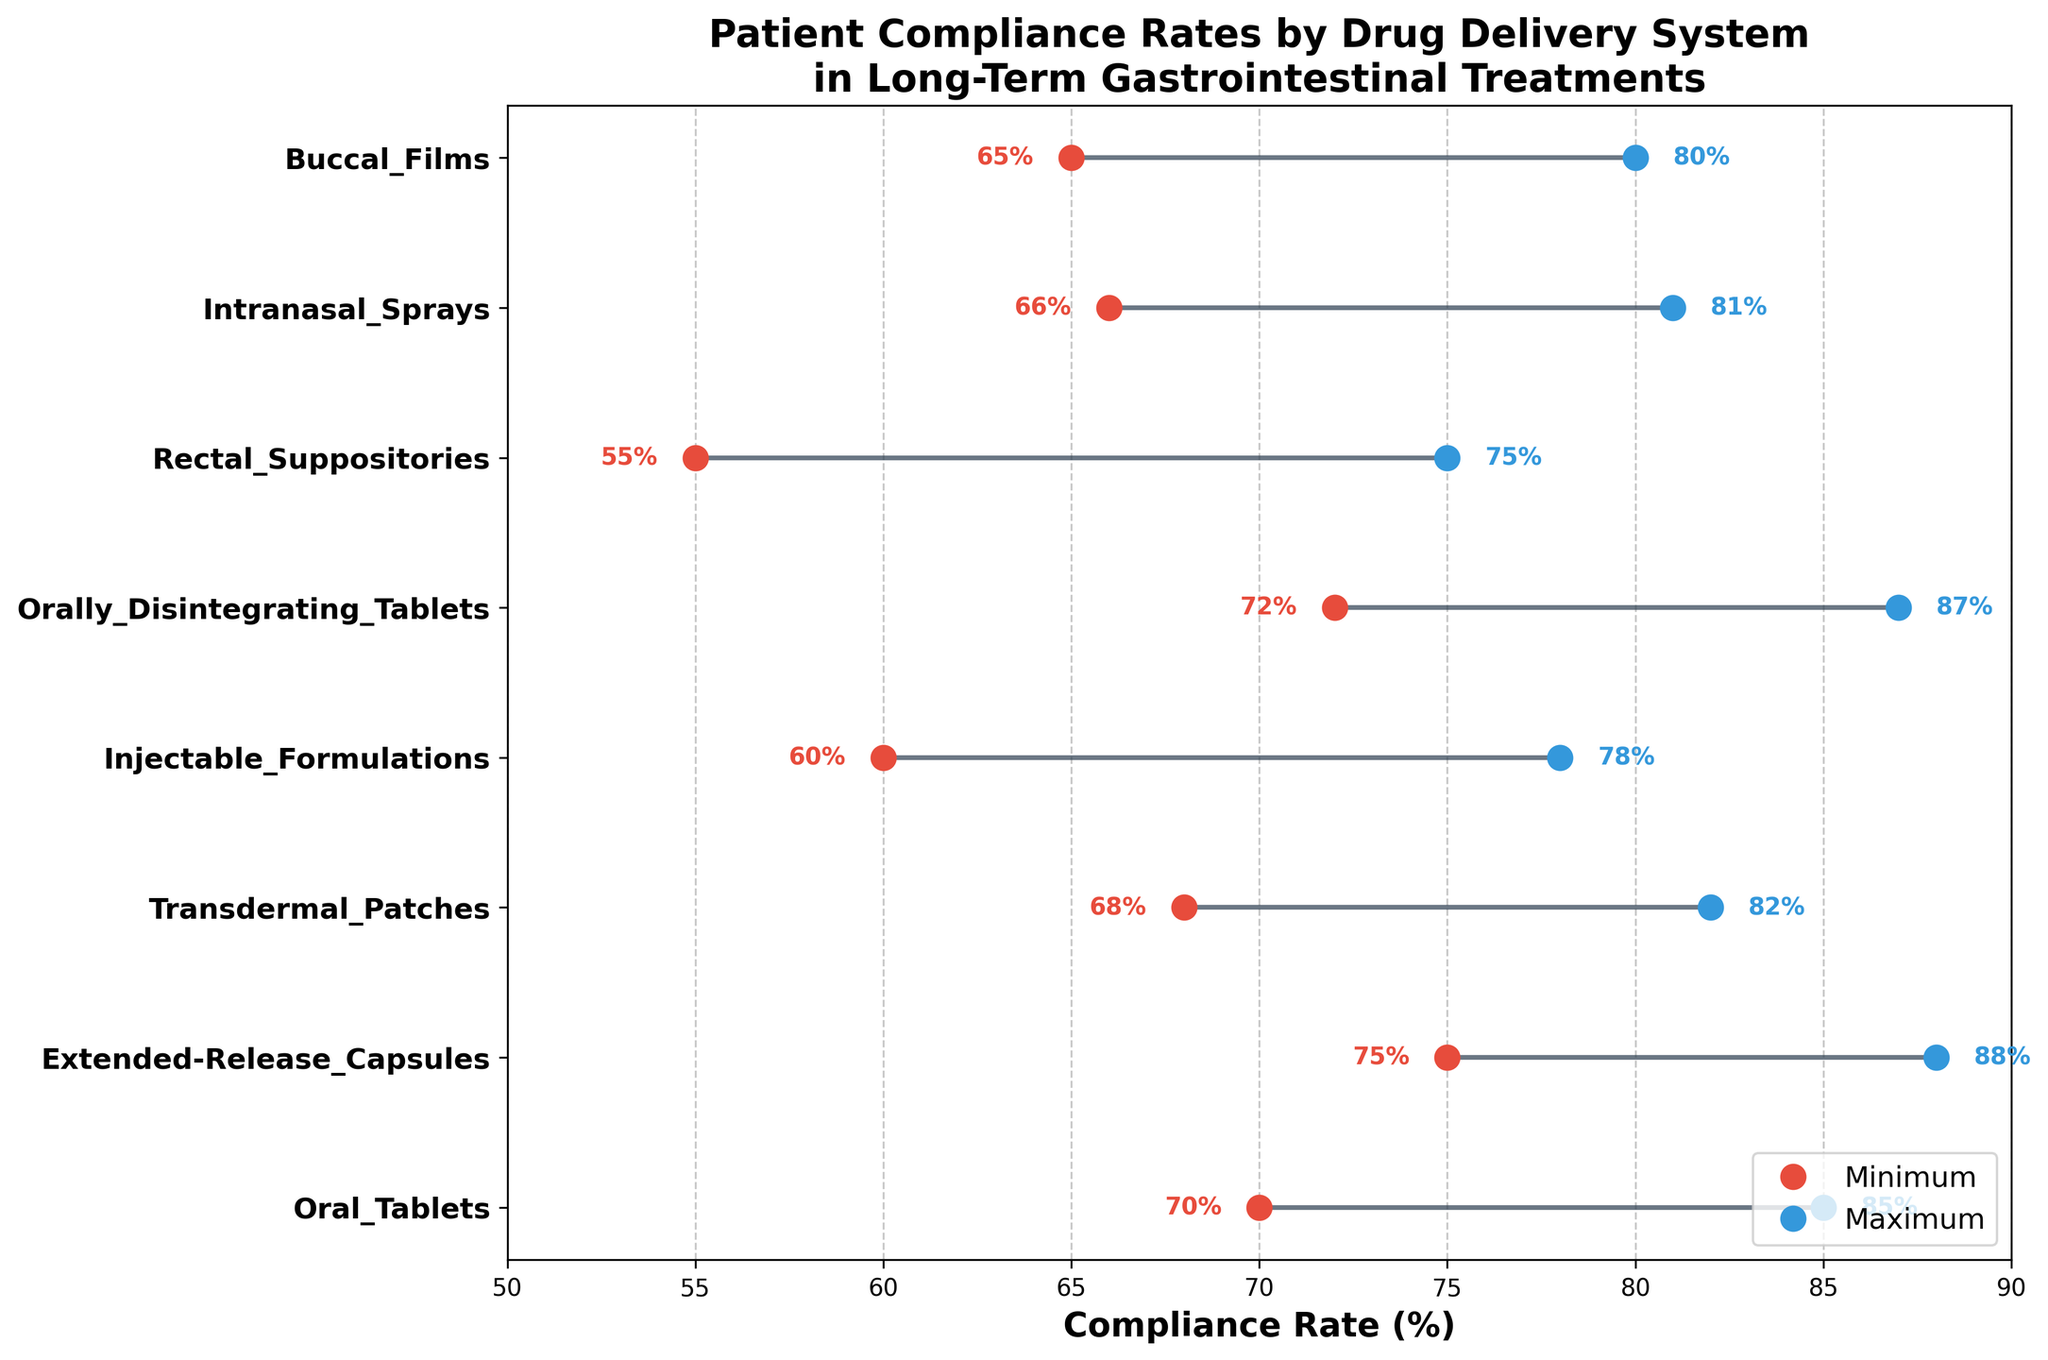What is the highest compliance maximum rate observed in the figure? The highest compliance maximum rate can be found by identifying the highest endpoint of the blue dots on the plot. The highest endpoint corresponds to Extended-Release Capsules with a maximum compliance rate of 88%.
Answer: 88% Which drug delivery system has the lowest compliance minimum rate? The lowest compliance minimum rate is represented by the leftmost red dot. According to the plot, Rectal Suppositories have the lowest compliance minimum rate of 55%.
Answer: Rectal Suppositories What is the range of compliance rates for Injectable Formulations? The range is calculated by subtracting the minimum compliance rate from the maximum compliance rate. According to the plot, for Injectable Formulations, the minimum is 60% and the maximum is 78%. The range is 78% - 60% = 18%.
Answer: 18% Which two drug delivery systems have the closest maximum compliance rates, and what are these rates? To find the closest maximum rates, identify the two systems whose blue dots are nearest to each other. Orally Disintegrating Tablets and Extended-Release Capsules have maximum rates very close to each other: 87% and 88%, respectively.
Answer: Orally Disintegrating Tablets (87%) and Extended-Release Capsules (88%) What is the average maximum compliance rate across all drug delivery systems? To find the average, add all the maximum compliance rates and divide by the number of drug delivery systems. The rates are 85, 88, 82, 78, 87, 75, 81, and 80. Sum = 656, divided by 8 systems gives an average of 82%.
Answer: 82% Which drug delivery system shows the widest range between its minimum and maximum compliance rates? The widest range is determined by finding the system with the largest difference between the red and blue dots. Rectal Suppositories have the widest range, with a minimum rate of 55% and a maximum rate of 75%, resulting in a 20% range.
Answer: Rectal Suppositories How many drug delivery systems have a minimum compliance rate above 65%? Count the systems where the red dot (minimum compliance rate) is above 65%. These systems are Oral Tablets (70%), Extended-Release Capsules (75%), Transdermal Patches (68%), Orally Disintegrating Tablets (72%), Intranasal Sprays (66%), and Buccal Films (65%). Hence, there are 6 systems.
Answer: 6 Which drug delivery system has the smallest difference between the minimum and maximum compliance rates? The smallest difference is found by identifying the system with the smallest gap between the red and blue dots. Intranasal Sprays have the smallest difference, with a minimum rate of 66% and a maximum rate of 81%, resulting in a 15% difference.
Answer: Intranasal Sprays Compare the maximum compliance rates of Transdermal Patches and Buccal Films. Which one is higher and by how much? Identify the blue dots for both systems and compare them. Transdermal Patches have a maximum rate of 82%, and Buccal Films have a maximum rate of 80%. The difference is 82% - 80% = 2%.
Answer: Transdermal Patches by 2% What is the median minimum compliance rate among all drug delivery systems? The median is found by ordering the minimum compliance rates (55, 60, 65, 66, 68, 70, 72, 75) and finding the middle value. Since there are 8 values, the median is the average of the 4th and 5th values: (66+68)/2 = 67%.
Answer: 67% 